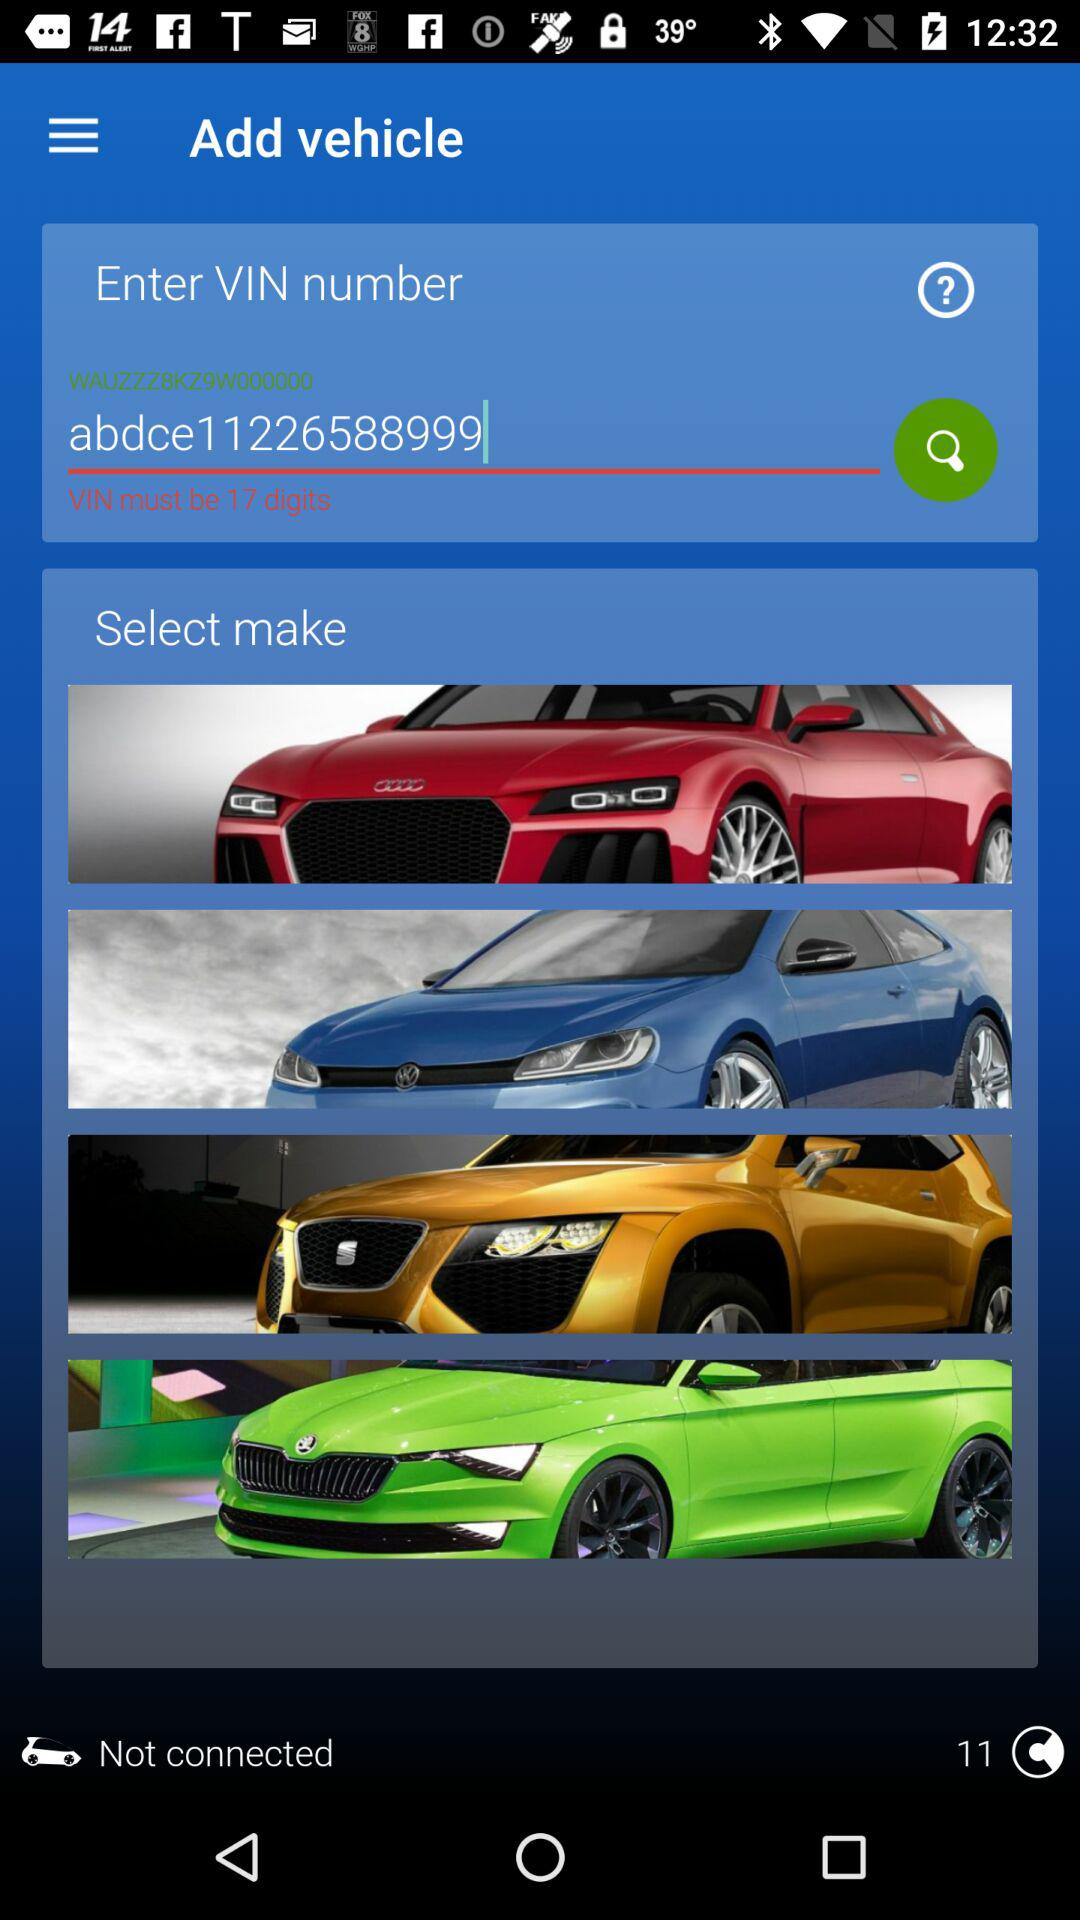How many online users are shown here?
When the provided information is insufficient, respond with <no answer>. <no answer> 